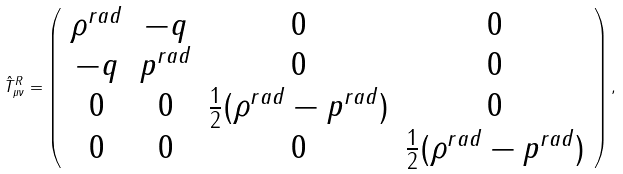<formula> <loc_0><loc_0><loc_500><loc_500>\hat { T } _ { \mu \nu } ^ { R } = \left ( \begin{array} { c c c c } \rho ^ { r a d } & - q & 0 & 0 \\ - q & p ^ { r a d } & 0 & 0 \\ 0 & 0 & \frac { 1 } { 2 } ( \rho ^ { r a d } - p ^ { r a d } ) & 0 \\ 0 & 0 & 0 & \frac { 1 } { 2 } ( \rho ^ { r a d } - p ^ { r a d } ) \end{array} \right ) ,</formula> 